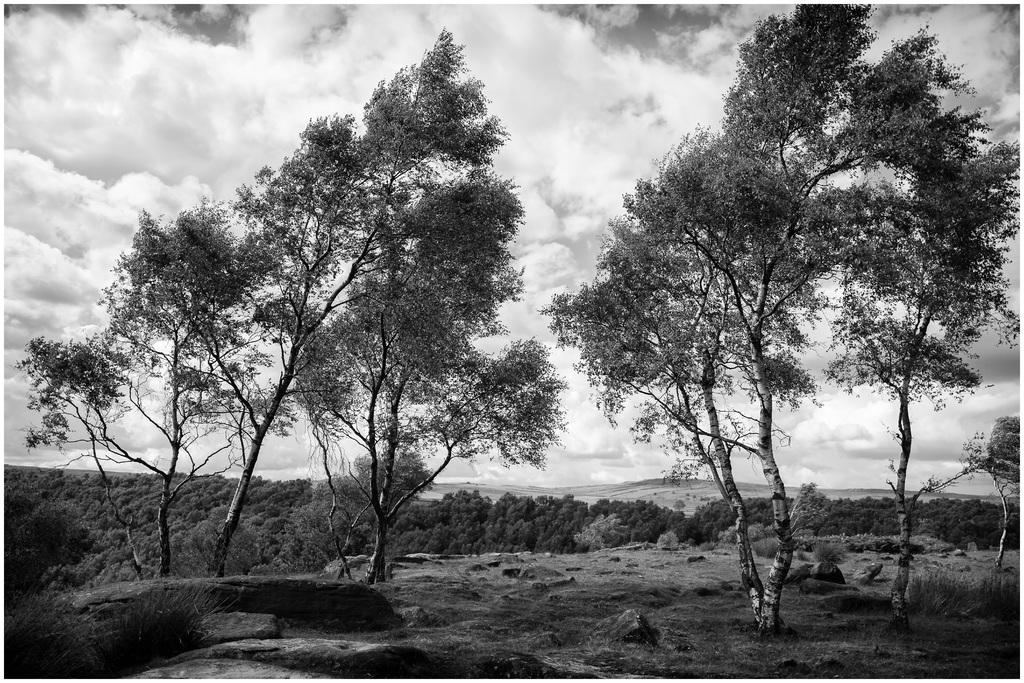What is the condition of the sky in the image? The sky is cloudy in the image. What type of natural vegetation can be seen in the image? There are trees visible in the image. What type of string is being used to measure the wealth of the trees in the image? There is no string or measurement of wealth present in the image; it only features a cloudy sky and trees. 